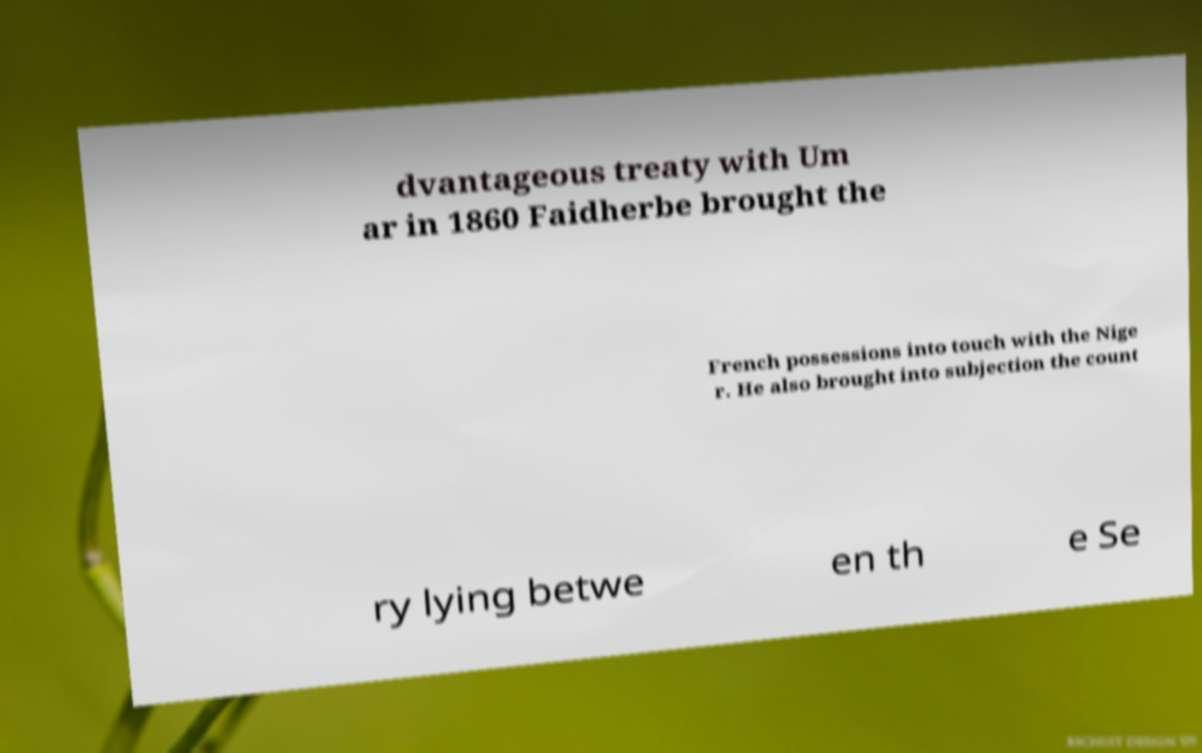Please identify and transcribe the text found in this image. dvantageous treaty with Um ar in 1860 Faidherbe brought the French possessions into touch with the Nige r. He also brought into subjection the count ry lying betwe en th e Se 